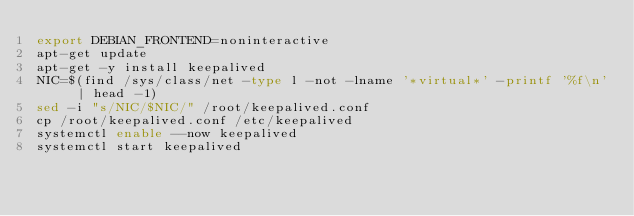Convert code to text. <code><loc_0><loc_0><loc_500><loc_500><_Bash_>export DEBIAN_FRONTEND=noninteractive
apt-get update 
apt-get -y install keepalived
NIC=$(find /sys/class/net -type l -not -lname '*virtual*' -printf '%f\n' | head -1)
sed -i "s/NIC/$NIC/" /root/keepalived.conf
cp /root/keepalived.conf /etc/keepalived
systemctl enable --now keepalived
systemctl start keepalived
</code> 